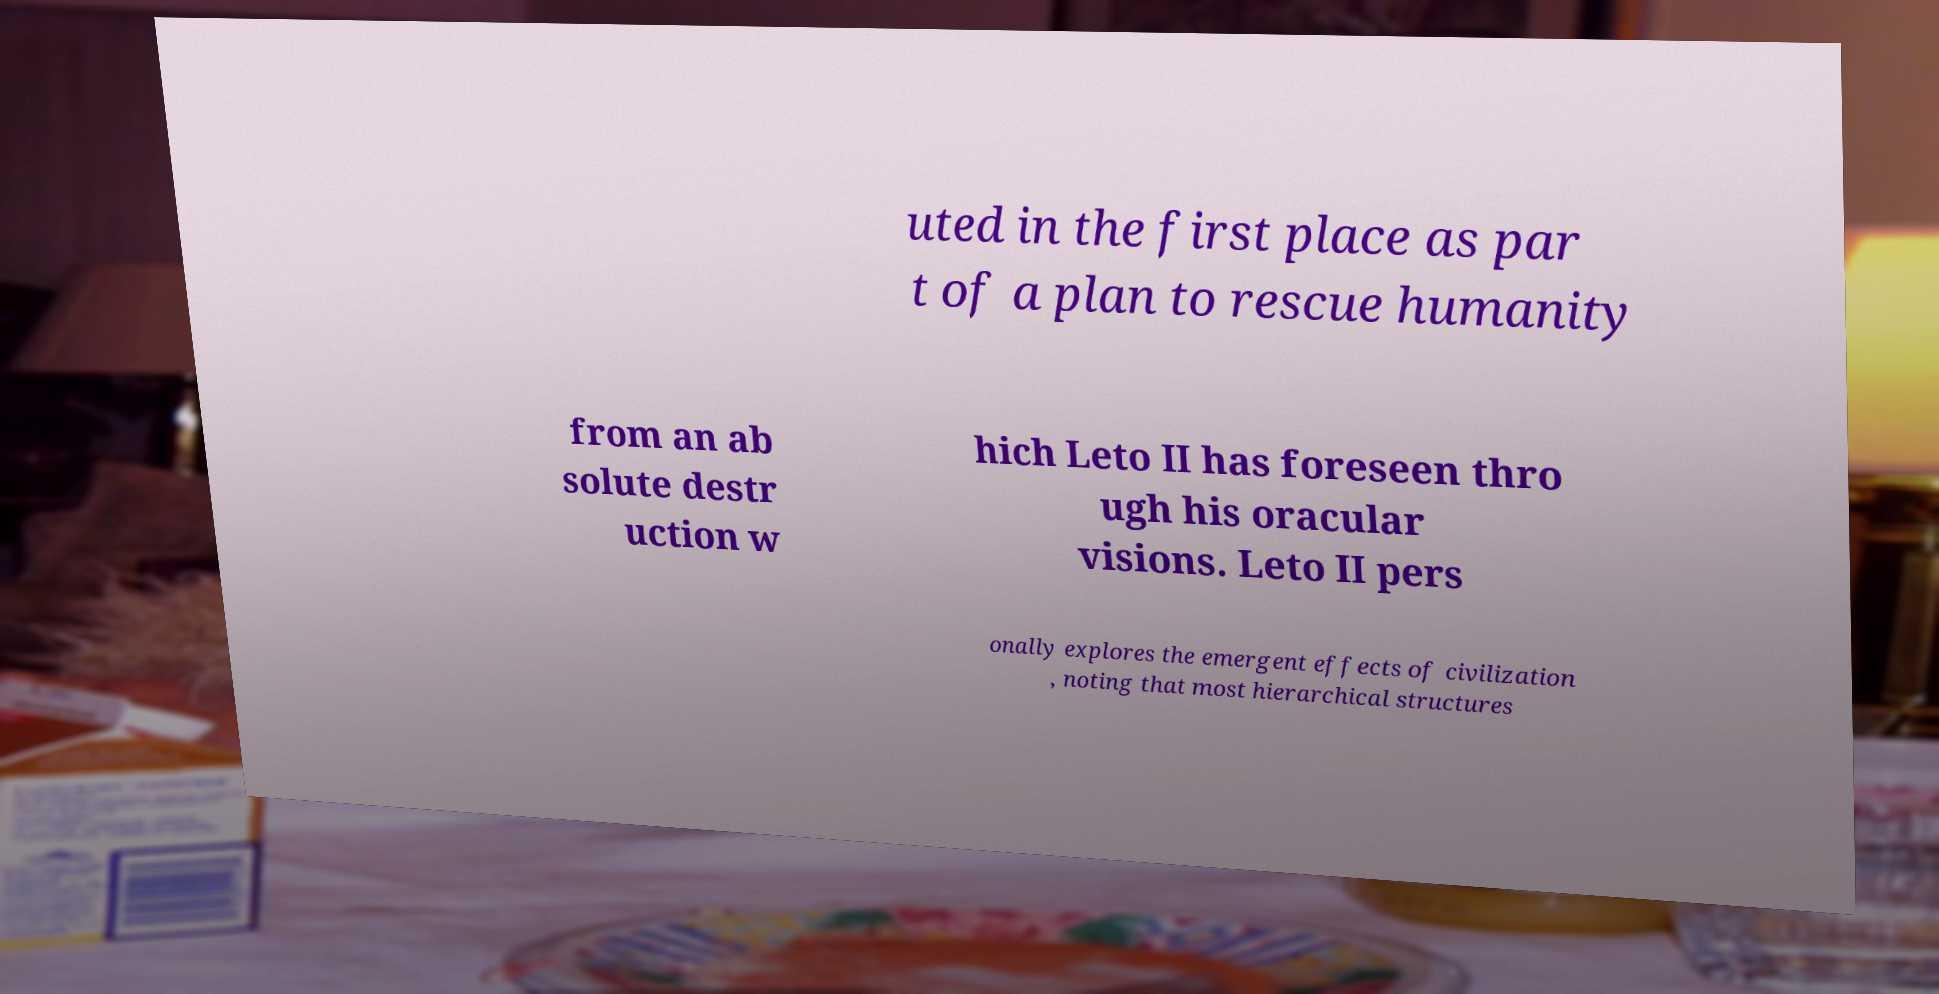What messages or text are displayed in this image? I need them in a readable, typed format. uted in the first place as par t of a plan to rescue humanity from an ab solute destr uction w hich Leto II has foreseen thro ugh his oracular visions. Leto II pers onally explores the emergent effects of civilization , noting that most hierarchical structures 